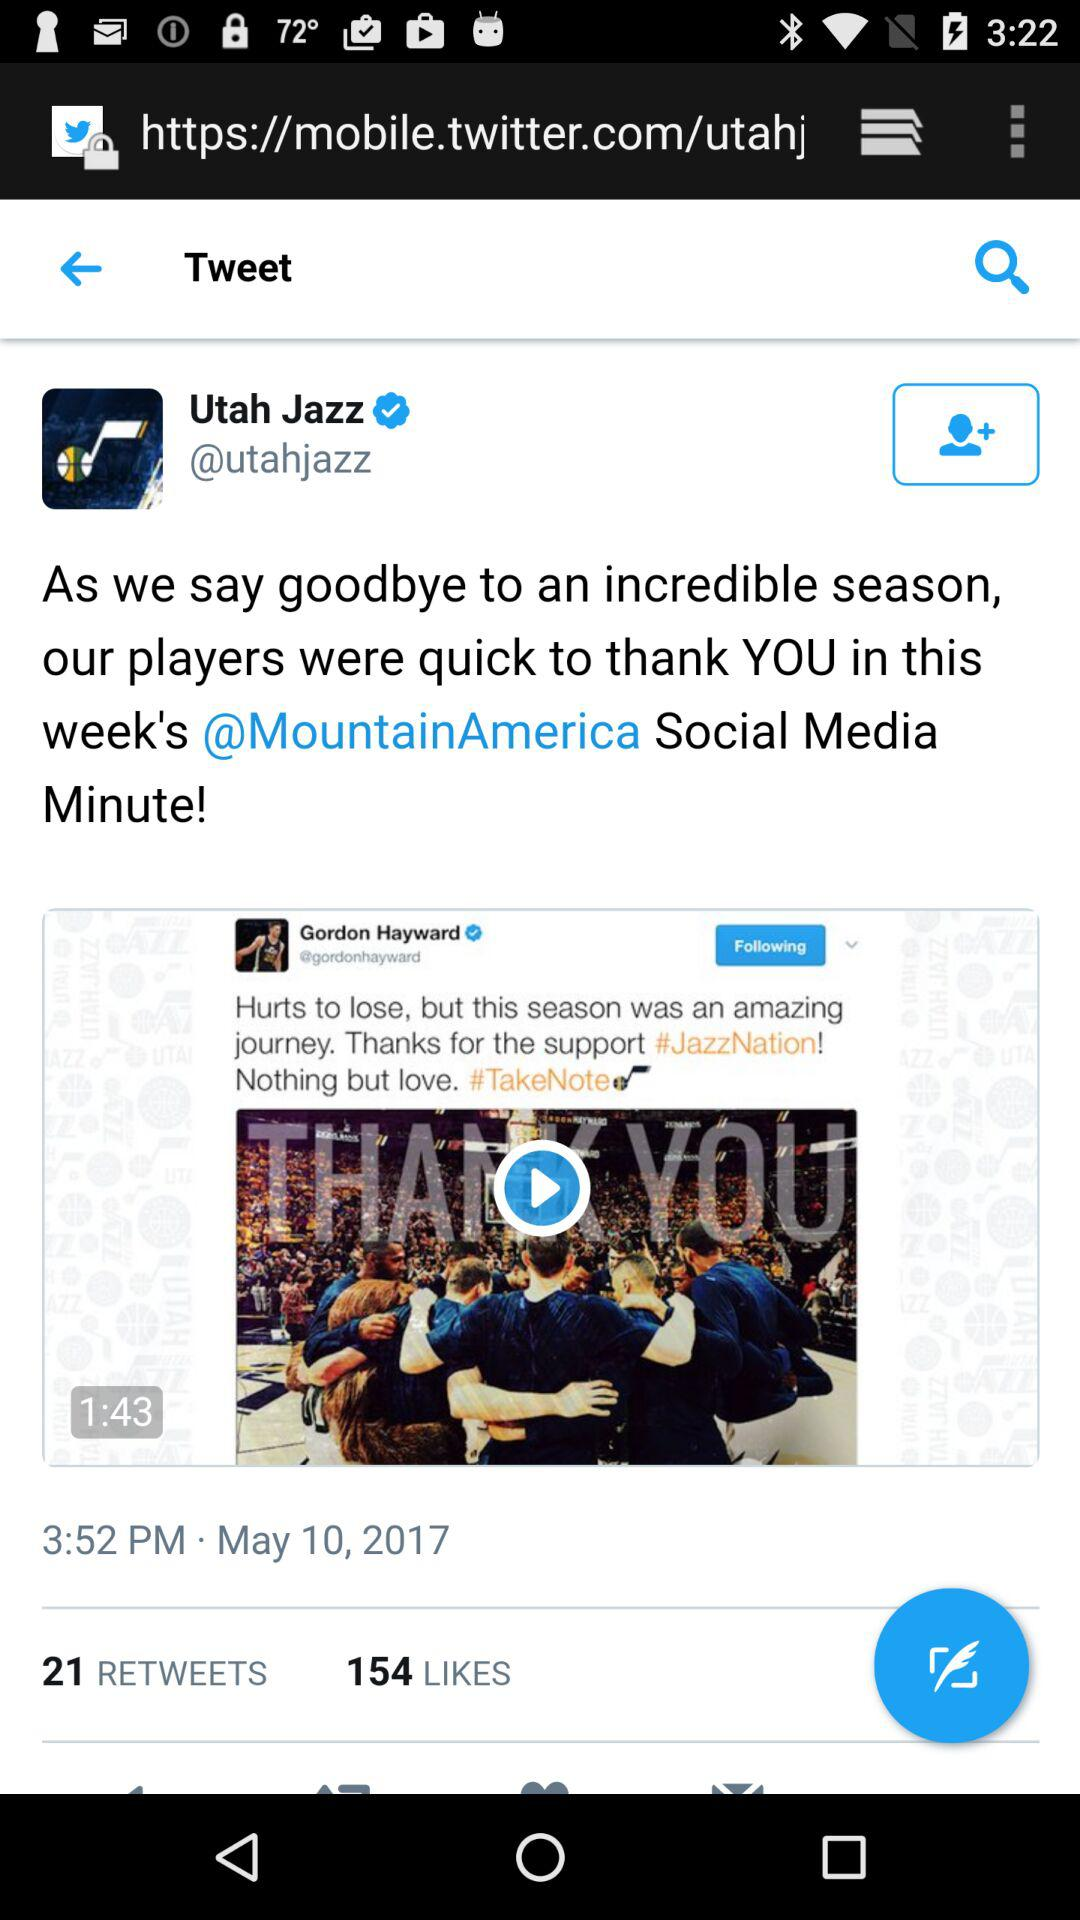At what time did the Utah Jazz update a tweet? The Utah Jazz updated a tweet at 3:52 pm. 